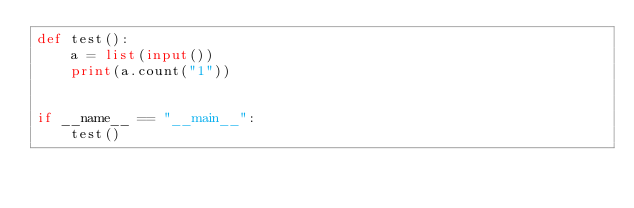<code> <loc_0><loc_0><loc_500><loc_500><_Python_>def test():
    a = list(input())
    print(a.count("1"))


if __name__ == "__main__":
    test()
</code> 